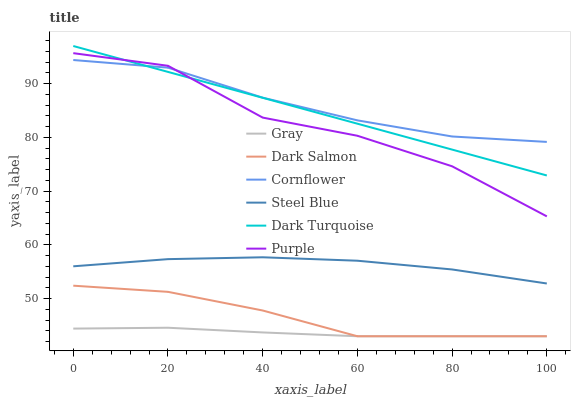Does Gray have the minimum area under the curve?
Answer yes or no. Yes. Does Cornflower have the maximum area under the curve?
Answer yes or no. Yes. Does Purple have the minimum area under the curve?
Answer yes or no. No. Does Purple have the maximum area under the curve?
Answer yes or no. No. Is Dark Turquoise the smoothest?
Answer yes or no. Yes. Is Purple the roughest?
Answer yes or no. Yes. Is Cornflower the smoothest?
Answer yes or no. No. Is Cornflower the roughest?
Answer yes or no. No. Does Gray have the lowest value?
Answer yes or no. Yes. Does Purple have the lowest value?
Answer yes or no. No. Does Dark Turquoise have the highest value?
Answer yes or no. Yes. Does Cornflower have the highest value?
Answer yes or no. No. Is Dark Salmon less than Steel Blue?
Answer yes or no. Yes. Is Purple greater than Steel Blue?
Answer yes or no. Yes. Does Gray intersect Dark Salmon?
Answer yes or no. Yes. Is Gray less than Dark Salmon?
Answer yes or no. No. Is Gray greater than Dark Salmon?
Answer yes or no. No. Does Dark Salmon intersect Steel Blue?
Answer yes or no. No. 